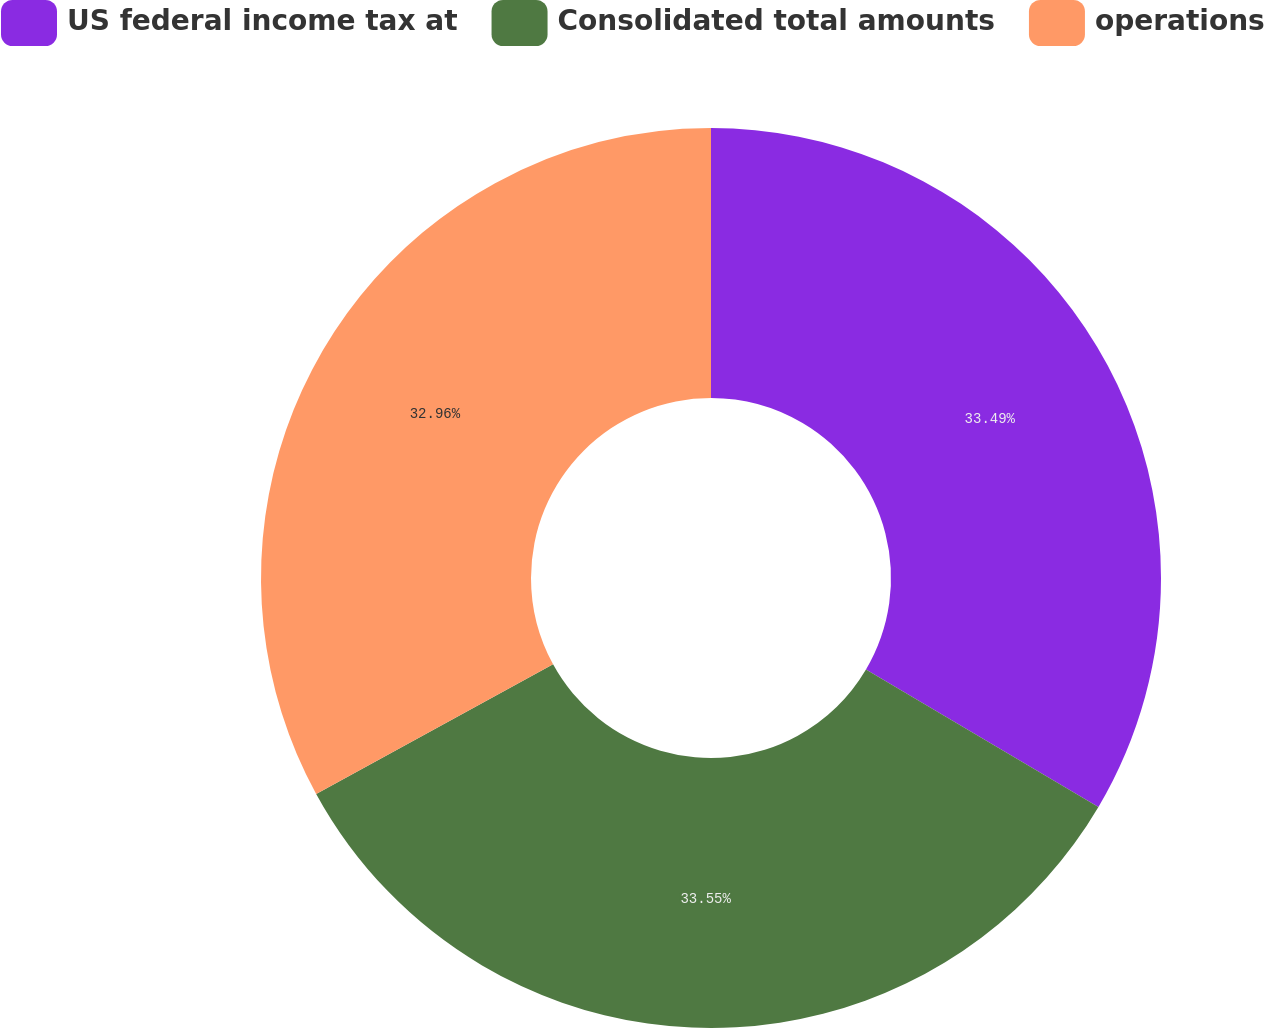Convert chart to OTSL. <chart><loc_0><loc_0><loc_500><loc_500><pie_chart><fcel>US federal income tax at<fcel>Consolidated total amounts<fcel>operations<nl><fcel>33.49%<fcel>33.54%<fcel>32.96%<nl></chart> 